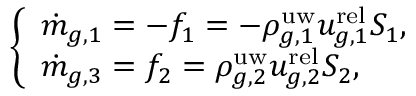<formula> <loc_0><loc_0><loc_500><loc_500>\left \{ \begin{array} { l l } { \dot { m } _ { g , 1 } = - f _ { 1 } = - \rho _ { g , 1 } ^ { u w } u _ { g , 1 } ^ { r e l } S _ { 1 } , } \\ { \dot { m } _ { g , 3 } = f _ { 2 } = \rho _ { g , 2 } ^ { u w } u _ { g , 2 } ^ { r e l } S _ { 2 } , } \end{array}</formula> 